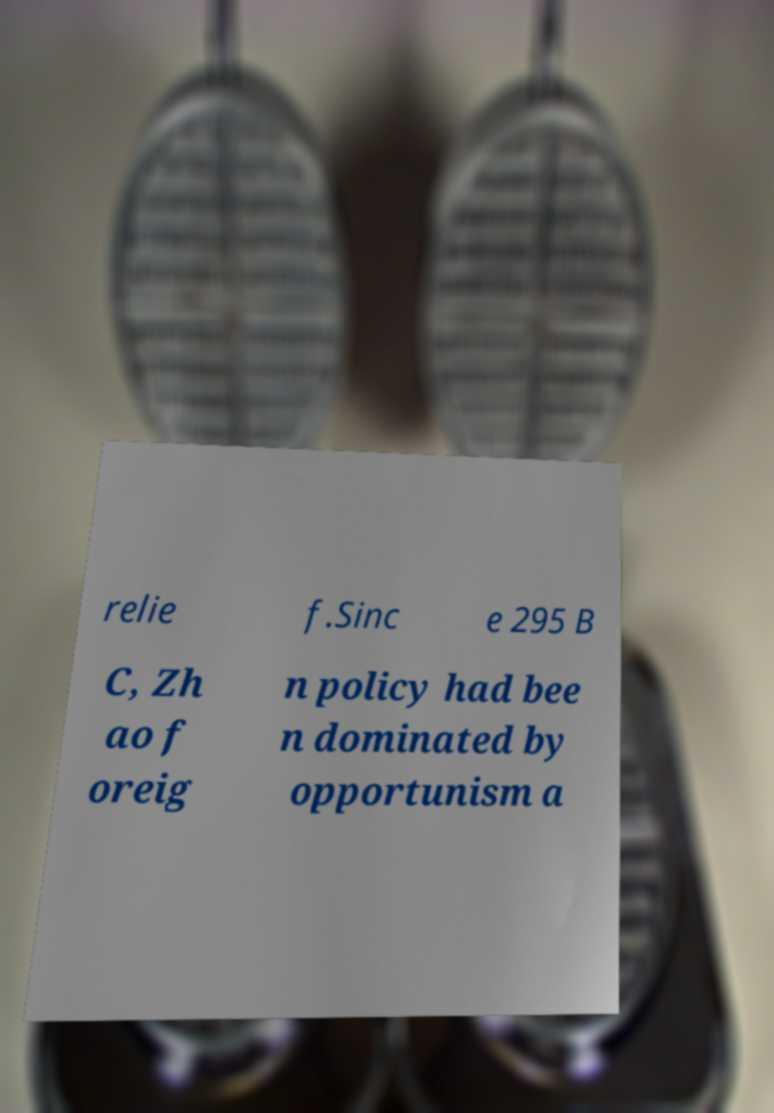Please identify and transcribe the text found in this image. relie f.Sinc e 295 B C, Zh ao f oreig n policy had bee n dominated by opportunism a 